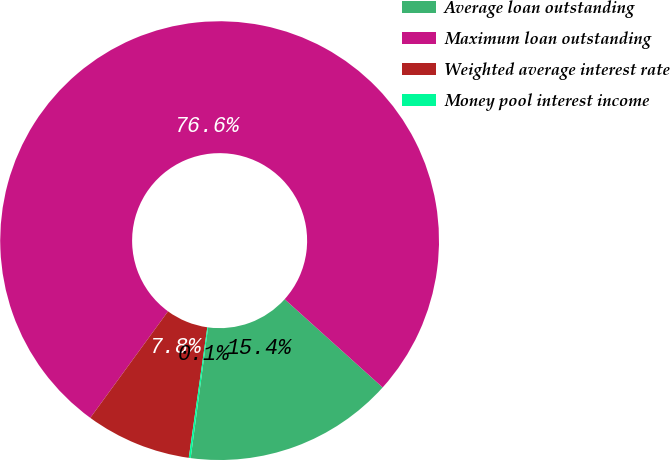<chart> <loc_0><loc_0><loc_500><loc_500><pie_chart><fcel>Average loan outstanding<fcel>Maximum loan outstanding<fcel>Weighted average interest rate<fcel>Money pool interest income<nl><fcel>15.44%<fcel>76.64%<fcel>7.79%<fcel>0.14%<nl></chart> 